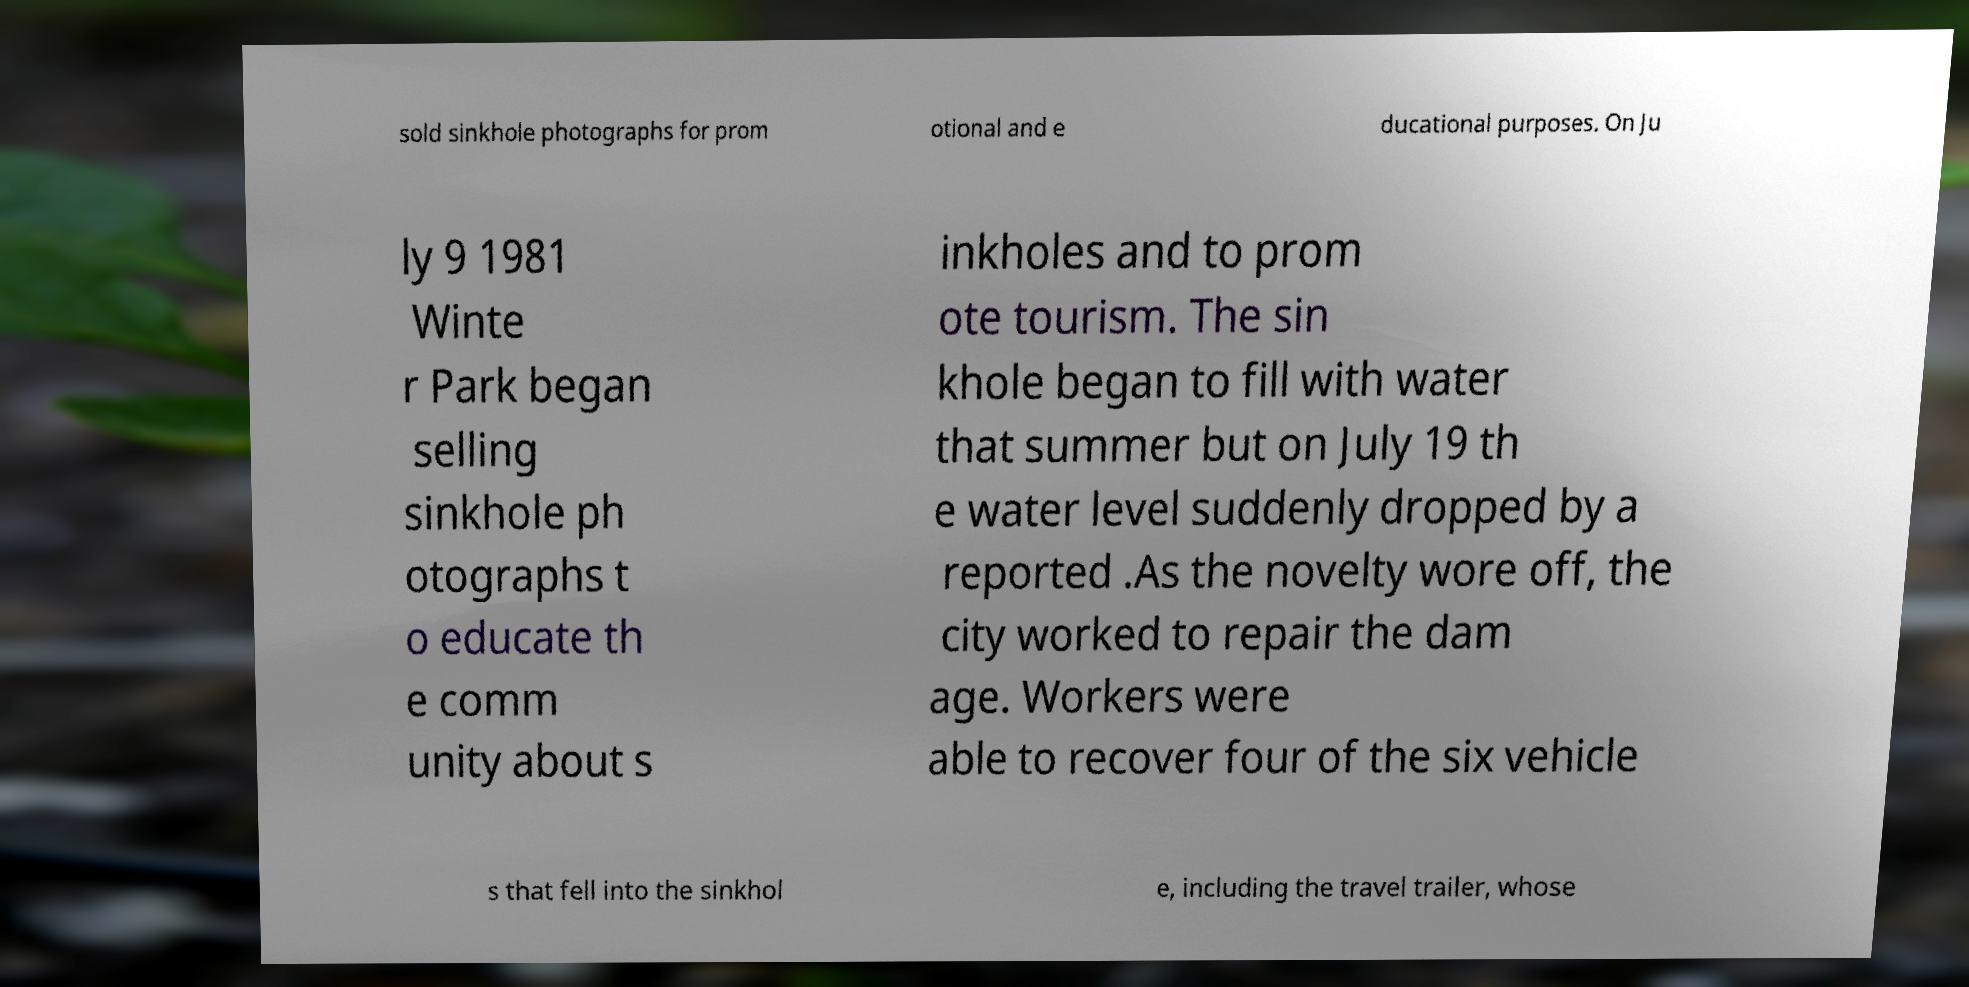Can you accurately transcribe the text from the provided image for me? sold sinkhole photographs for prom otional and e ducational purposes. On Ju ly 9 1981 Winte r Park began selling sinkhole ph otographs t o educate th e comm unity about s inkholes and to prom ote tourism. The sin khole began to fill with water that summer but on July 19 th e water level suddenly dropped by a reported .As the novelty wore off, the city worked to repair the dam age. Workers were able to recover four of the six vehicle s that fell into the sinkhol e, including the travel trailer, whose 